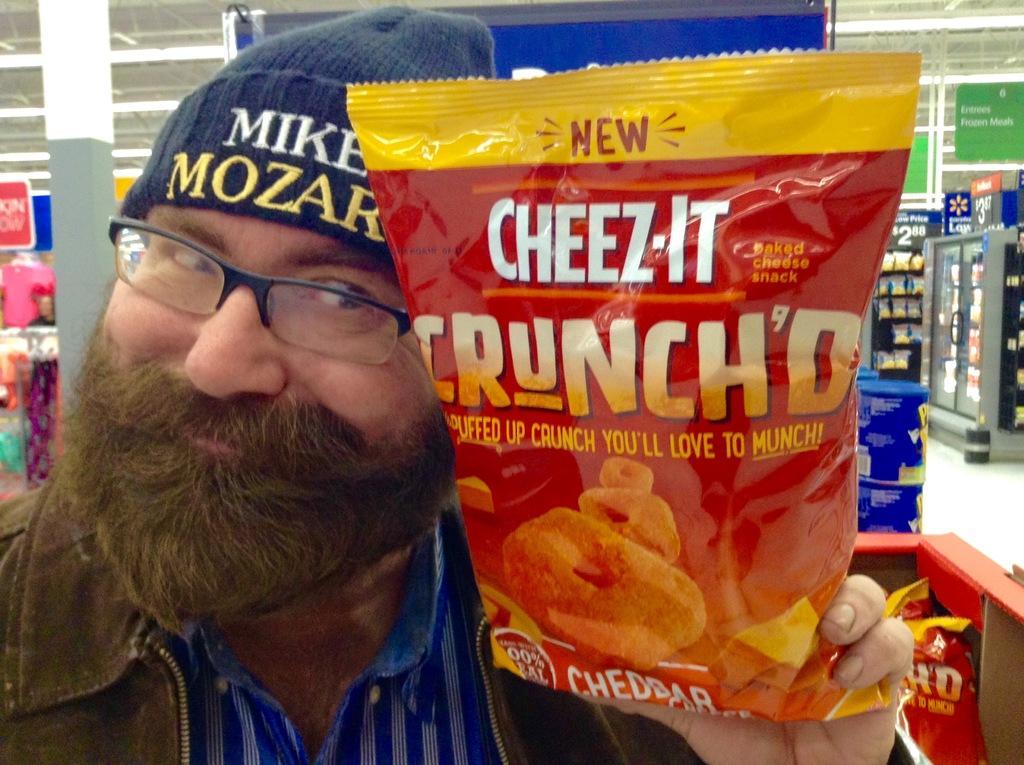Could you give a brief overview of what you see in this image? In this image there is a person holding a chips packet, and in the background there are boxes, clothes, pillars, lights, boards, packets in the refrigerator and racks. 